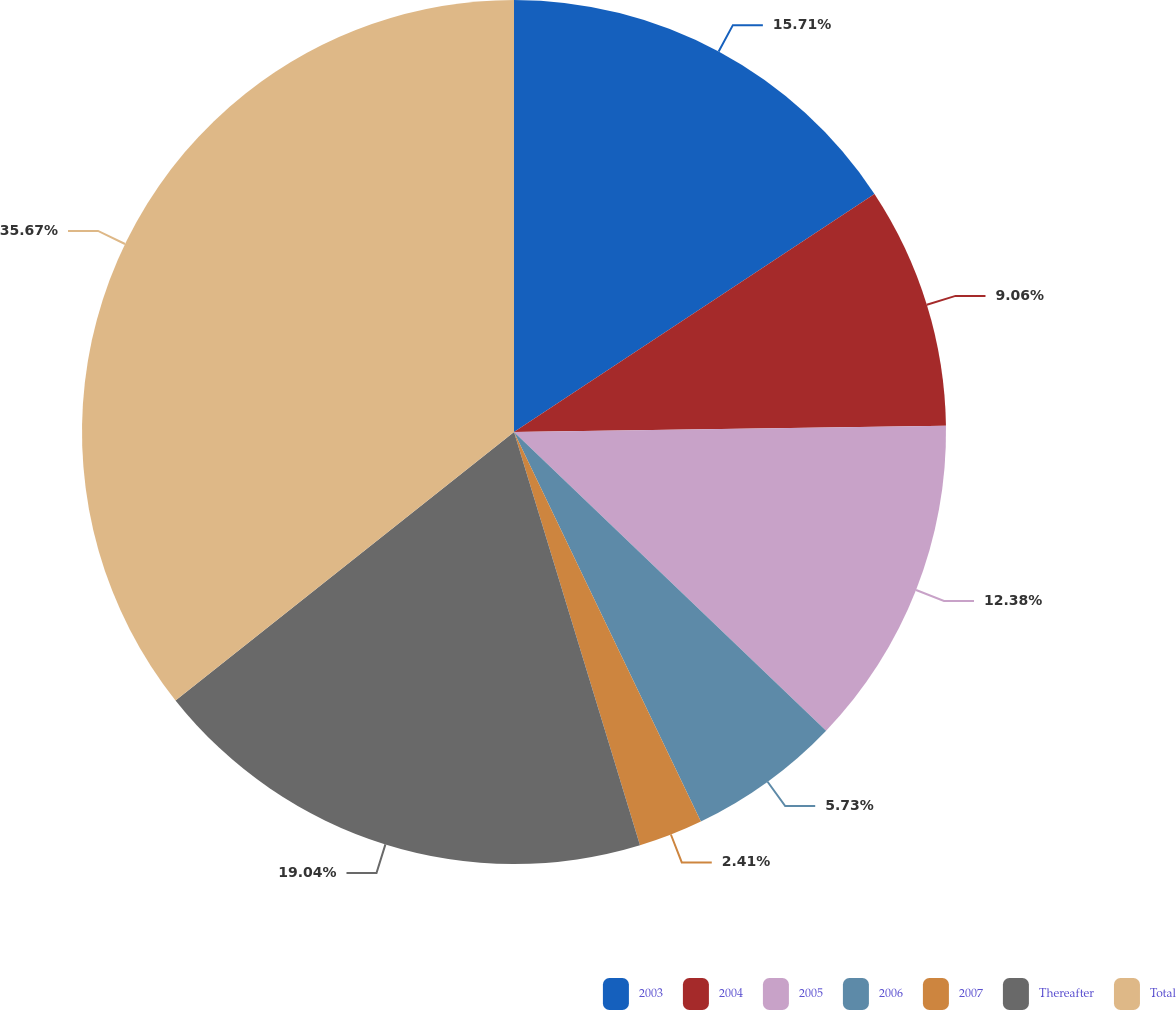Convert chart to OTSL. <chart><loc_0><loc_0><loc_500><loc_500><pie_chart><fcel>2003<fcel>2004<fcel>2005<fcel>2006<fcel>2007<fcel>Thereafter<fcel>Total<nl><fcel>15.71%<fcel>9.06%<fcel>12.38%<fcel>5.73%<fcel>2.41%<fcel>19.04%<fcel>35.67%<nl></chart> 